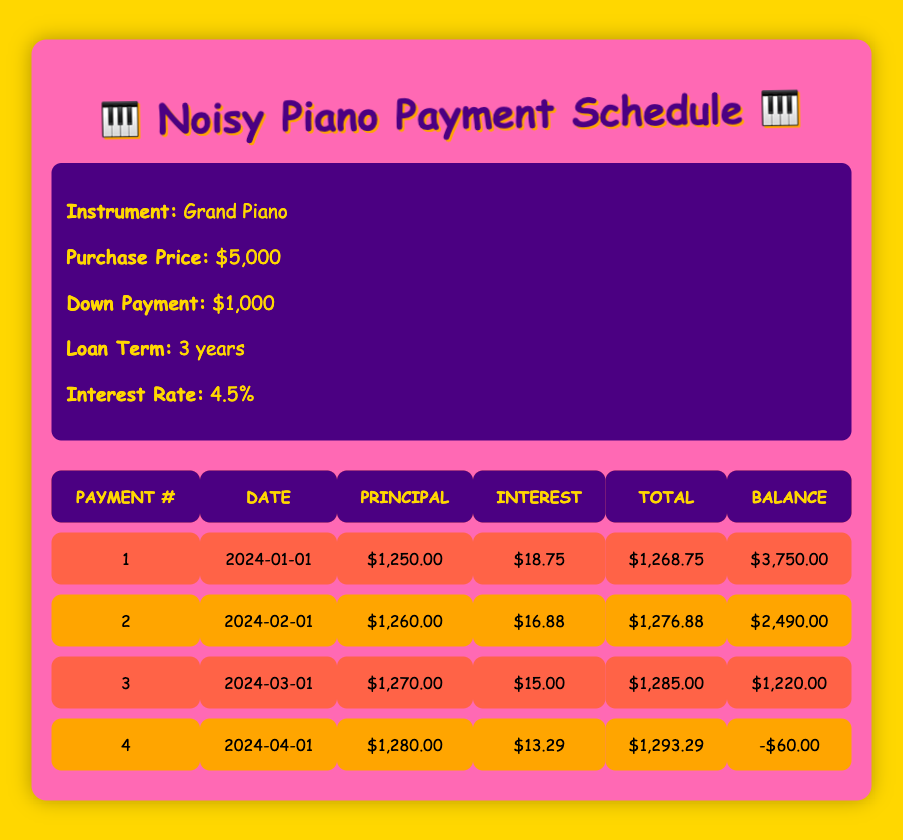What is the total amount paid in the first payment? The table shows the first payment total amount as $1,268.75, directly listed under the "Total" column for payment number 1.
Answer: 1,268.75 What is the principal payment amount for the second payment? The table indicates that the principal payment for the second payment is $1,260.00, as shown in the "Principal" column for payment number 2.
Answer: 1,260.00 Is the total payment amount for the fourth payment higher than the principal payment? For the fourth payment, the total payment is $1,293.29, while the principal payment is $1,280.00; since $1,293.29 is greater than $1,280.00, the statement is true.
Answer: Yes What is the average interest payment across all four months? The interest payments are $18.75, $16.88, $15.00, and $13.29. Sum them (18.75 + 16.88 + 15.00 + 13.29 = 64.92) and divide by 4 gives an average of $64.92 / 4 = $16.23.
Answer: 16.23 If each subsequent payment reduces the balance, what was the remaining balance after the third payment? The balance after the third payment is shown as $1,220.00 in the "Balance" column for payment number 3. This value corresponds directly to that specific payment.
Answer: 1,220.00 What is the total amount paid over all four payments? Adding the total payments together: $1,268.75 + $1,276.88 + $1,285.00 + $1,293.29 gives $5,123.92, representing the total paid over the whole schedule.
Answer: 5,123.92 Did the principal payment amount increase with each payment? Comparing the principal amounts: $1,250.00, $1,260.00, $1,270.00, and $1,280.00 shows an increase in each payment, confirming the statement is true.
Answer: Yes What is the total amount of interest paid in the last payment? The interest payment for the last (fourth) payment is $13.29, and that amount is directly listed under the "Interest" column for payment number 4.
Answer: 13.29 